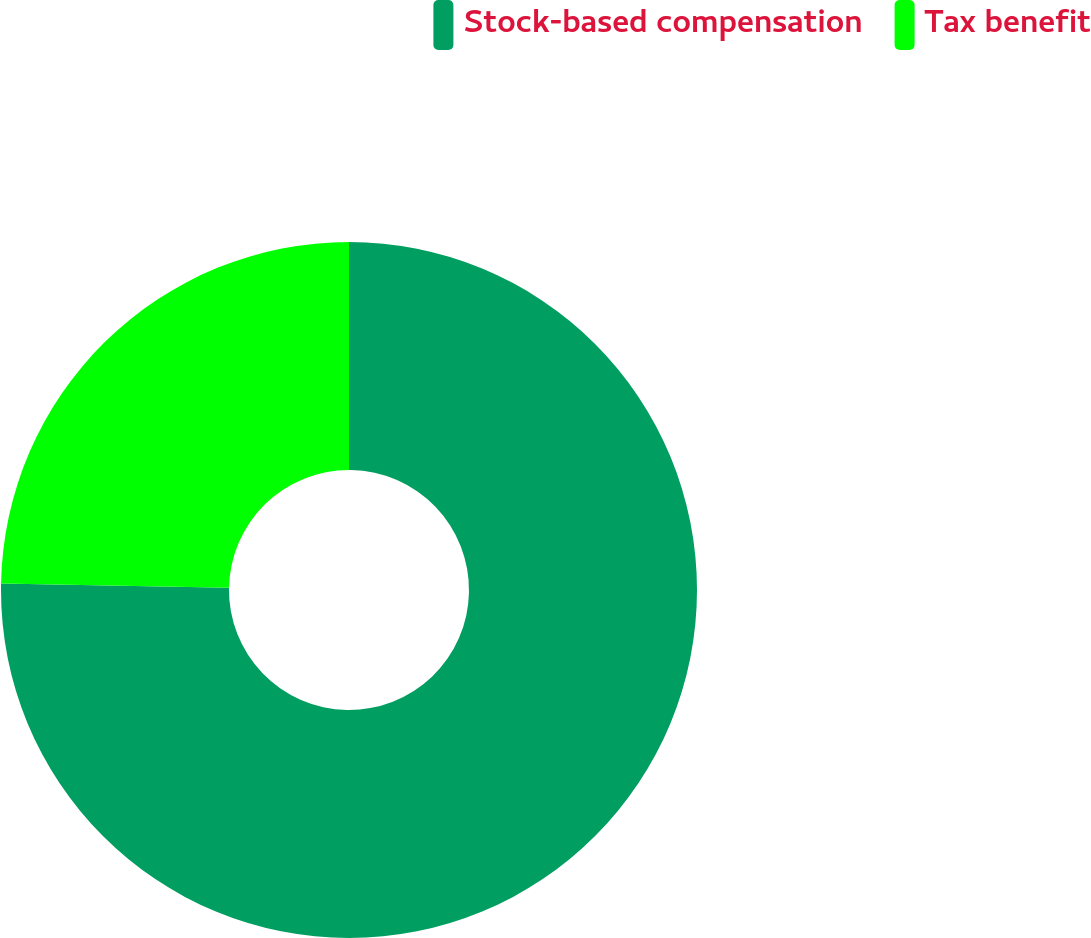Convert chart. <chart><loc_0><loc_0><loc_500><loc_500><pie_chart><fcel>Stock-based compensation<fcel>Tax benefit<nl><fcel>75.3%<fcel>24.7%<nl></chart> 